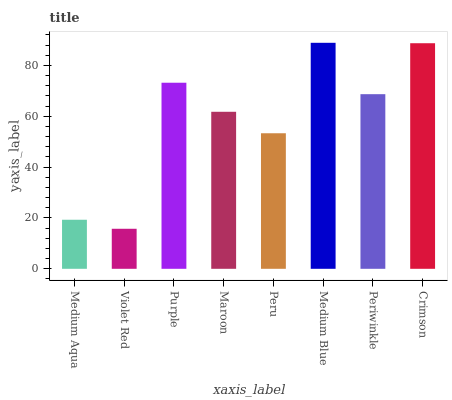Is Violet Red the minimum?
Answer yes or no. Yes. Is Medium Blue the maximum?
Answer yes or no. Yes. Is Purple the minimum?
Answer yes or no. No. Is Purple the maximum?
Answer yes or no. No. Is Purple greater than Violet Red?
Answer yes or no. Yes. Is Violet Red less than Purple?
Answer yes or no. Yes. Is Violet Red greater than Purple?
Answer yes or no. No. Is Purple less than Violet Red?
Answer yes or no. No. Is Periwinkle the high median?
Answer yes or no. Yes. Is Maroon the low median?
Answer yes or no. Yes. Is Purple the high median?
Answer yes or no. No. Is Crimson the low median?
Answer yes or no. No. 